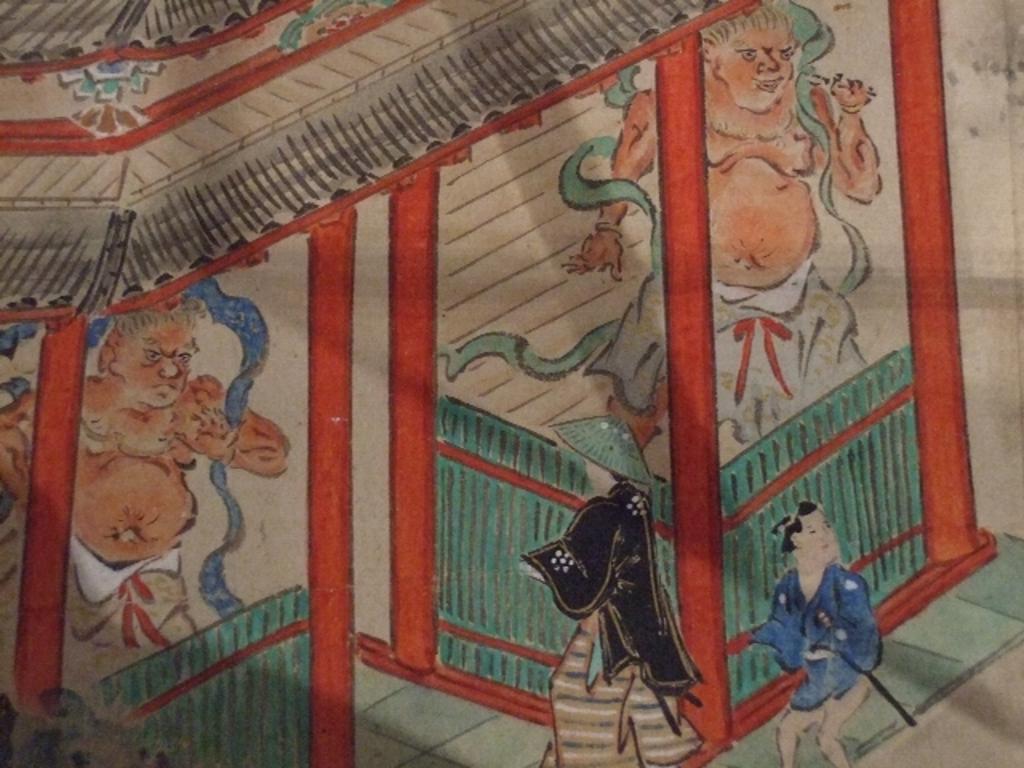In one or two sentences, can you explain what this image depicts? In this image, we can see depiction of persons and shelter. 